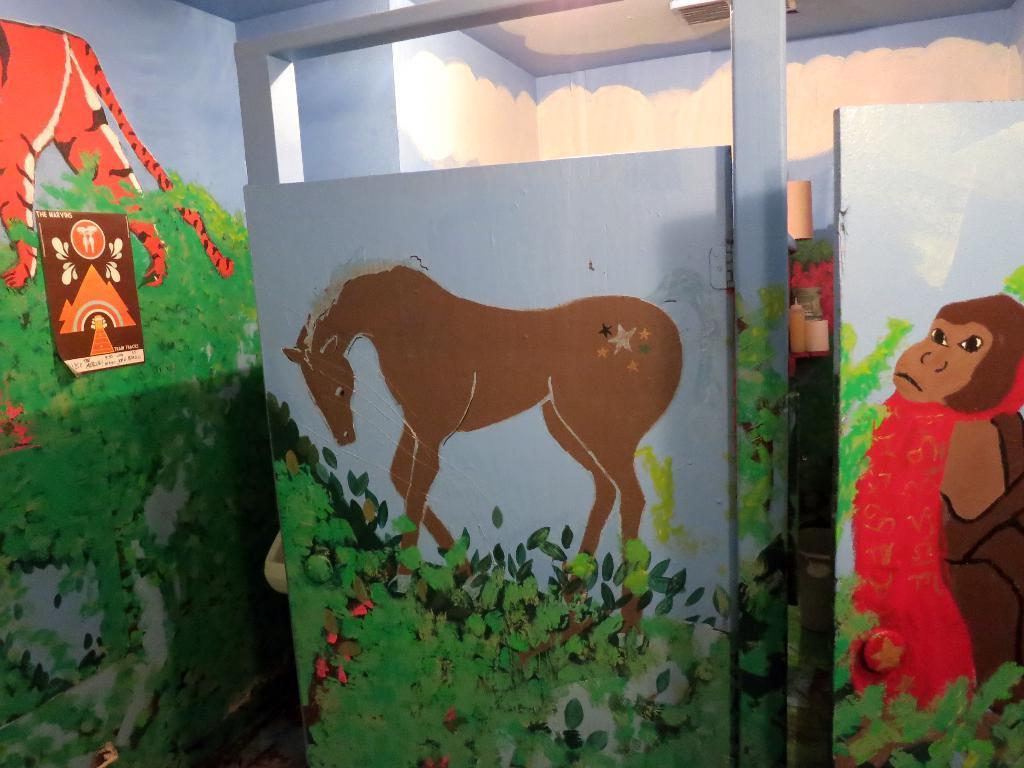Please provide a concise description of this image. In the picture we can see some wall in the home which are painted with a greenery and some horse, monkey and on the door and behind the door we can see another room. 